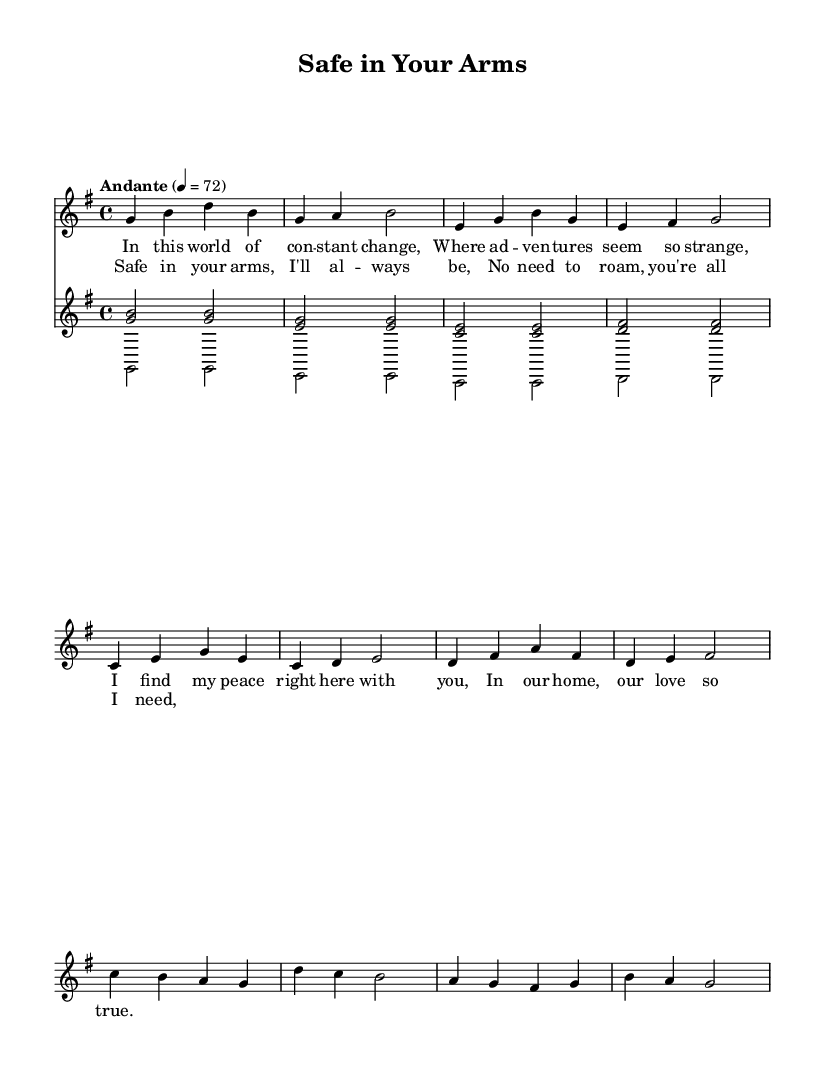What is the key signature of this music? The key signature is G major, which has one sharp (F#). The key is indicated at the beginning of the staff with a sharp symbol on the F line.
Answer: G major What is the time signature of this music? The time signature is 4/4, which is shown at the beginning of the score where it indicates four beats per measure.
Answer: 4/4 What tempo marking is indicated for this music? The tempo marking is "Andante" with a metronome marking of 72 beats per minute. This is indicated at the beginning of the score.
Answer: Andante, 72 How many measures are in the verse section? The verse section consists of 8 measures, counted by identifying each bar line in the voice staff.
Answer: 8 What is the dynamic marking for the voice part? The dynamic marking for the voice part is "up", which is indicated right before the first note of the voice part.
Answer: Up What is the theme of the lyrics in this piece? The theme of the lyrics revolves around finding comfort in a long-term relationship, as expressed through lines about peace and love in a stable home.
Answer: Comfort in love How does the chord progression in the chorus compare to the verse? In the chorus, the chord progression emphasizes a feeling of resolution and safety, contrasting with the more exploratory feeling of the verse, which focuses on change and peace.
Answer: Resolution and safety 